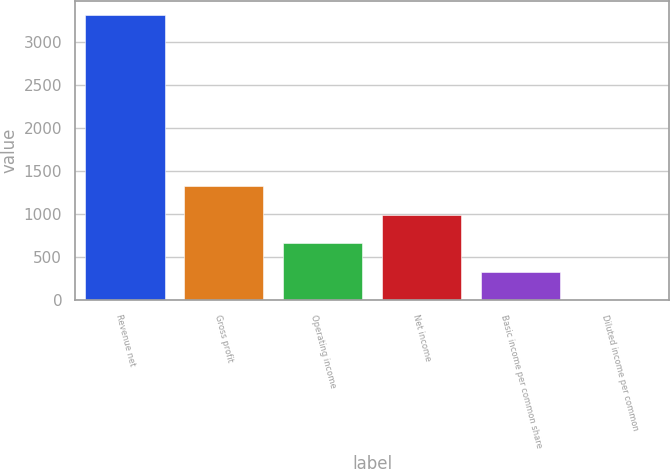Convert chart to OTSL. <chart><loc_0><loc_0><loc_500><loc_500><bar_chart><fcel>Revenue net<fcel>Gross profit<fcel>Operating income<fcel>Net income<fcel>Basic income per common share<fcel>Diluted income per common<nl><fcel>3317<fcel>1327.43<fcel>664.25<fcel>995.84<fcel>332.66<fcel>1.07<nl></chart> 